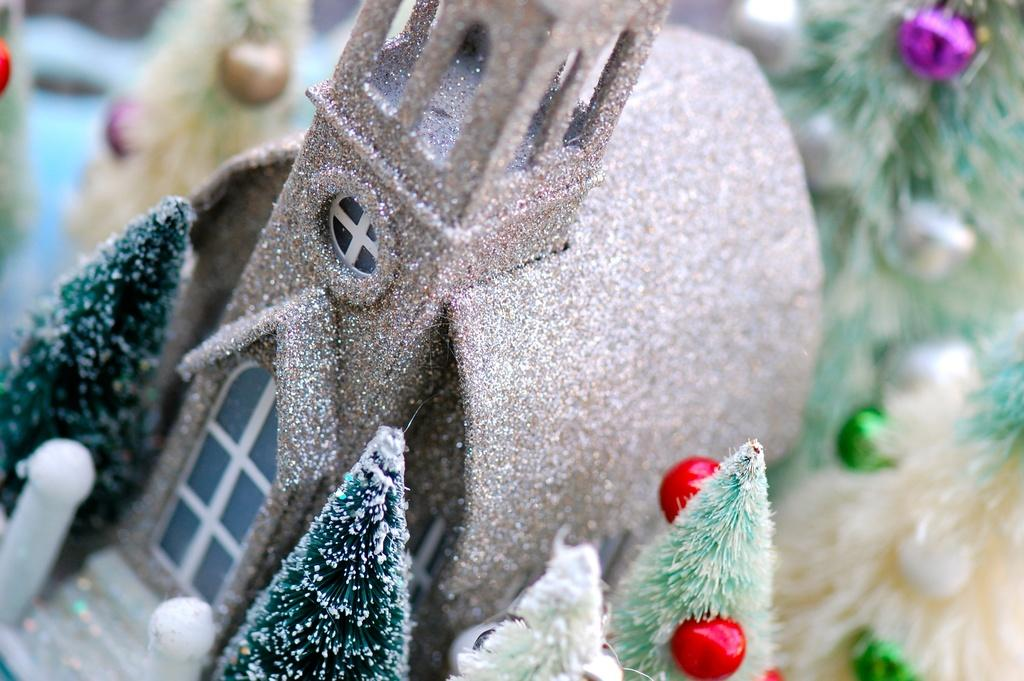What is the main object in the front of the image? There is a toy building in the front of the image. What type of decorations can be seen in the image? There are Christmas trees in the image. How would you describe the background of the image? The background of the image is blurry. What type of body is visible in the image? There is no body present in the image; it features a toy building and Christmas trees. How many buns can be seen in the image? There are no buns present in the image. 